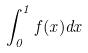Convert formula to latex. <formula><loc_0><loc_0><loc_500><loc_500>\int _ { 0 } ^ { 1 } f ( x ) d x</formula> 